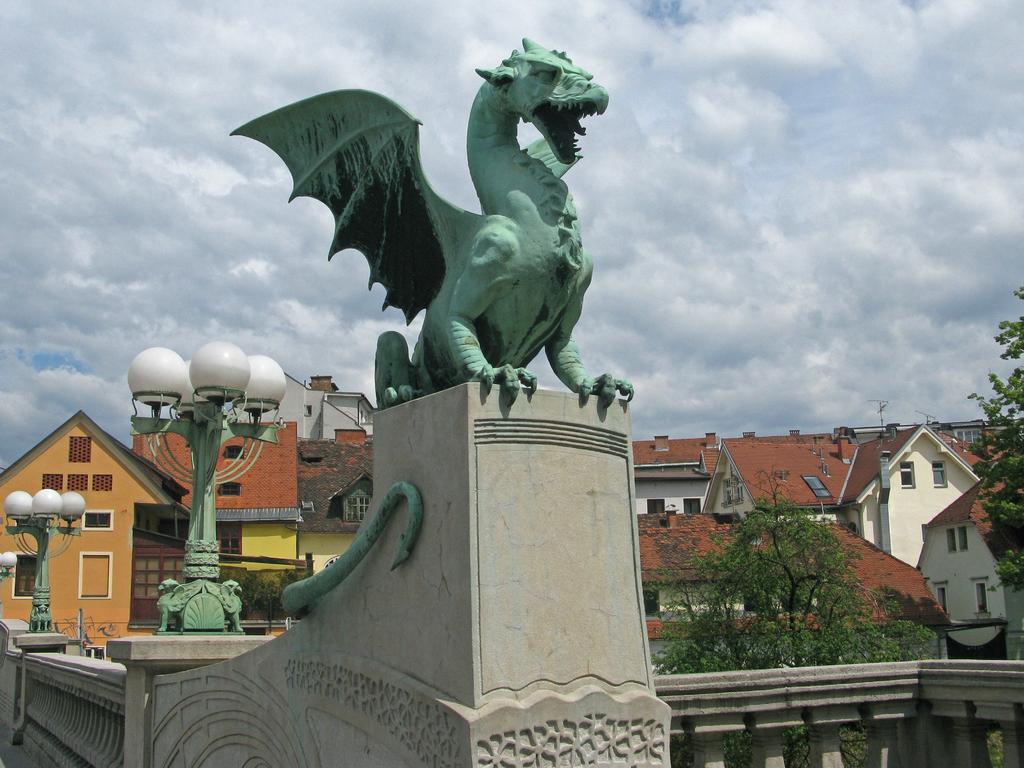Can you describe this image briefly? In the center of the image we can see a statue. We can also see a fence, a group of houses with roof and windows, some street lamps, trees and the sky which looks cloudy. 